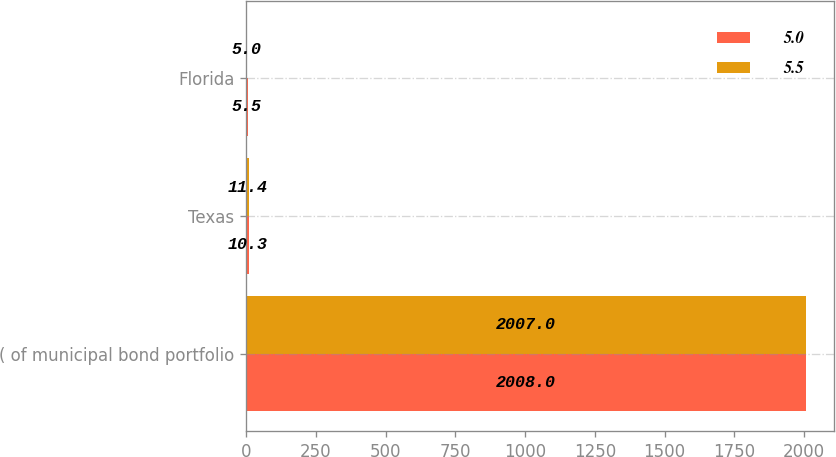Convert chart to OTSL. <chart><loc_0><loc_0><loc_500><loc_500><stacked_bar_chart><ecel><fcel>( of municipal bond portfolio<fcel>Texas<fcel>Florida<nl><fcel>5<fcel>2008<fcel>10.3<fcel>5.5<nl><fcel>5.5<fcel>2007<fcel>11.4<fcel>5<nl></chart> 